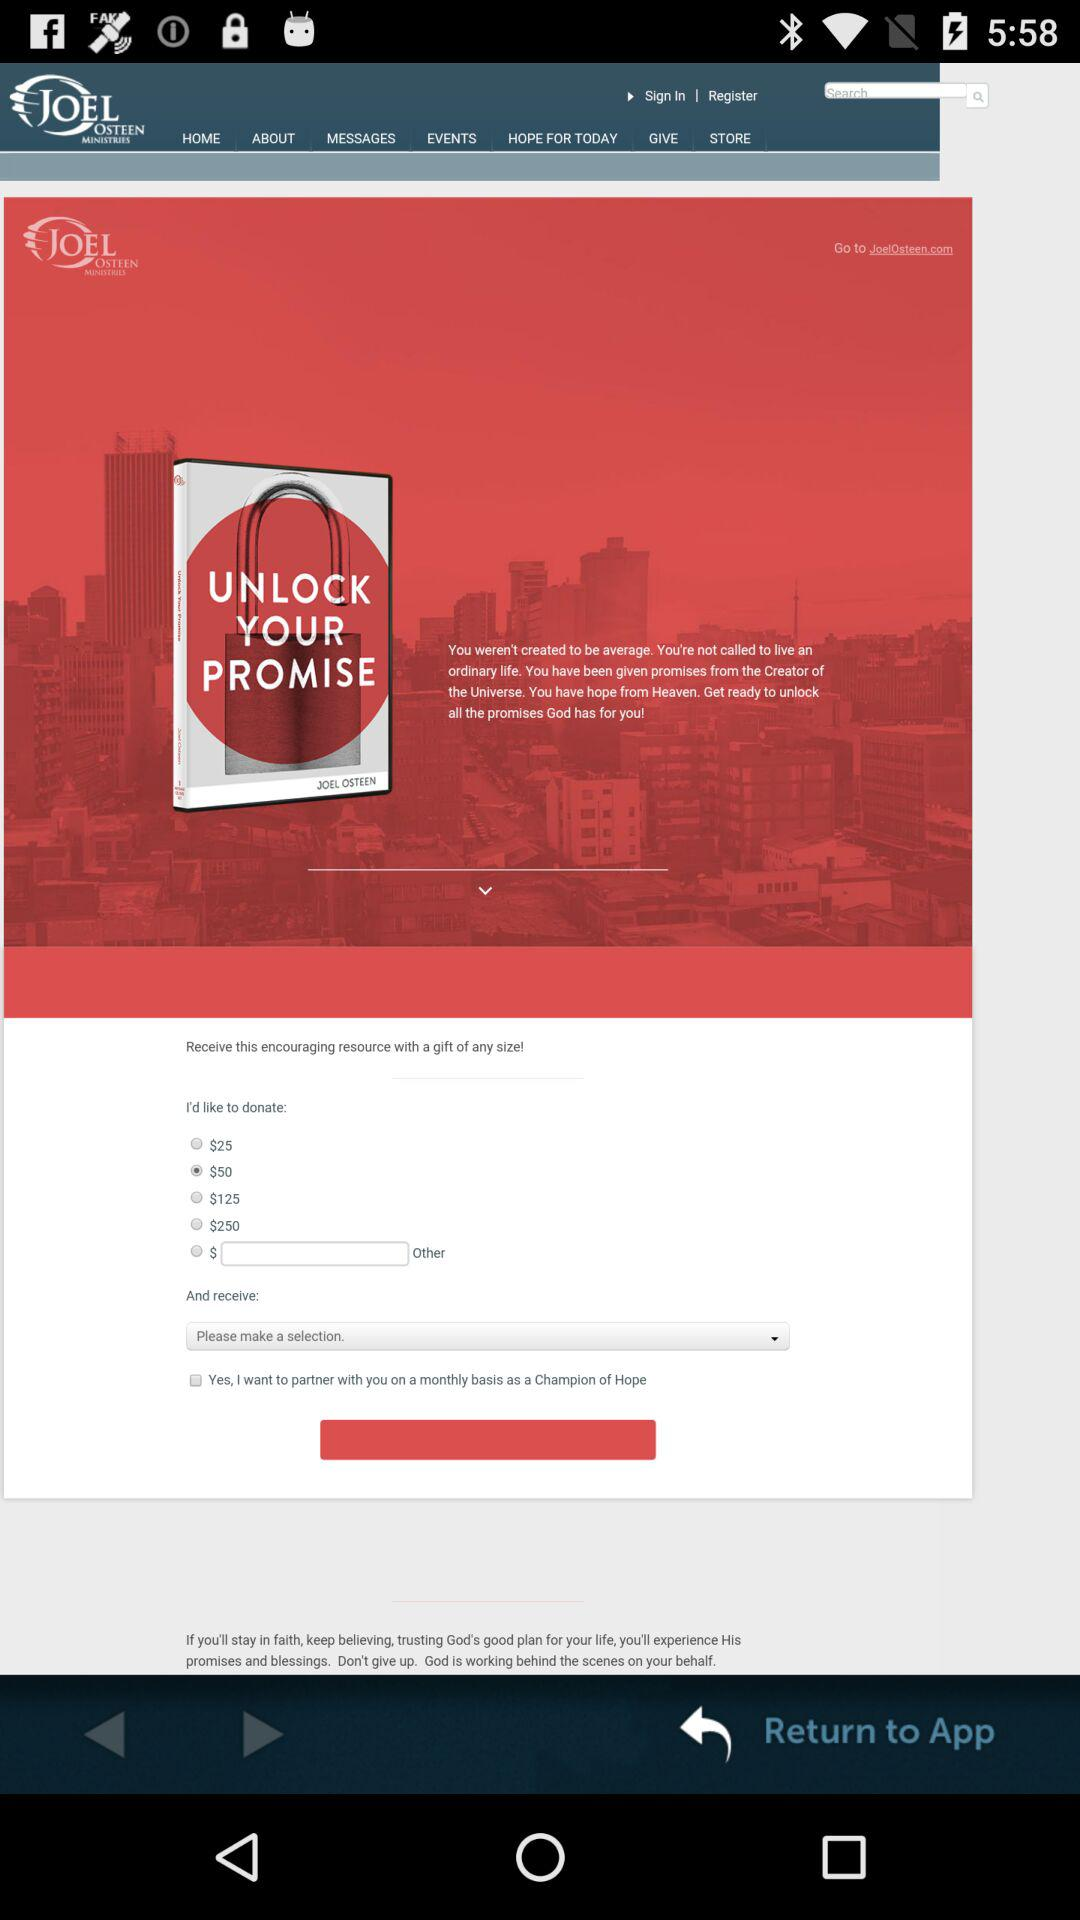What is the application name? The application name is "JOEL OSTEEN". 